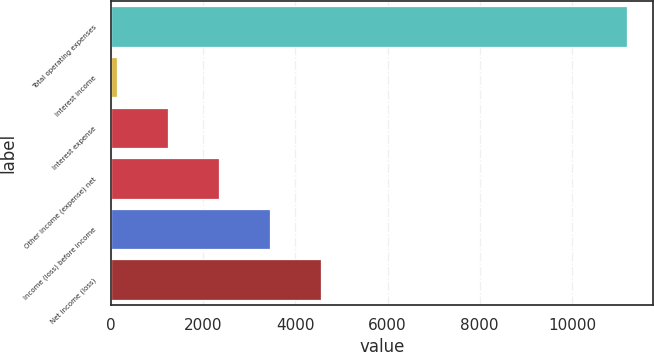Convert chart. <chart><loc_0><loc_0><loc_500><loc_500><bar_chart><fcel>Total operating expenses<fcel>Interest income<fcel>Interest expense<fcel>Other income (expense) net<fcel>Income (loss) before income<fcel>Net income (loss)<nl><fcel>11199<fcel>123<fcel>1230.6<fcel>2338.2<fcel>3445.8<fcel>4553.4<nl></chart> 